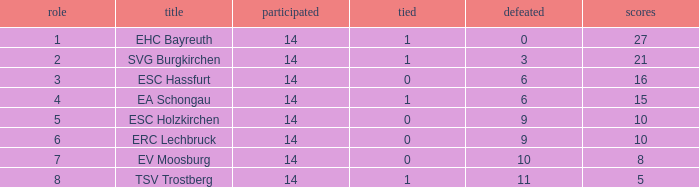What's the lost when there were more than 16 points and had a drawn less than 1? None. 